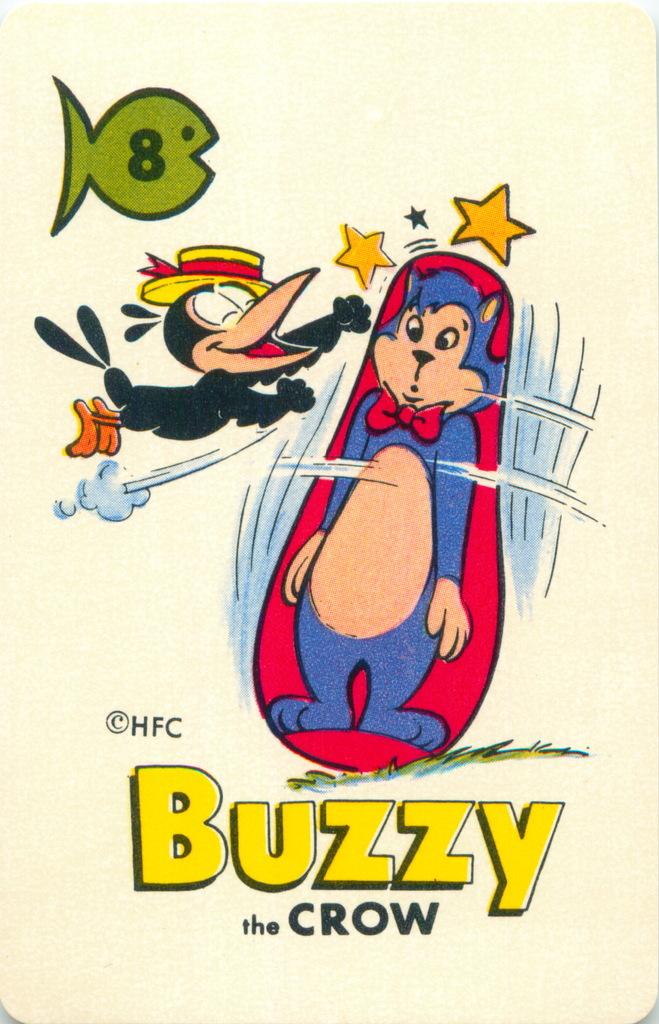What is the crow's name?
Your response must be concise. Buzzy. 